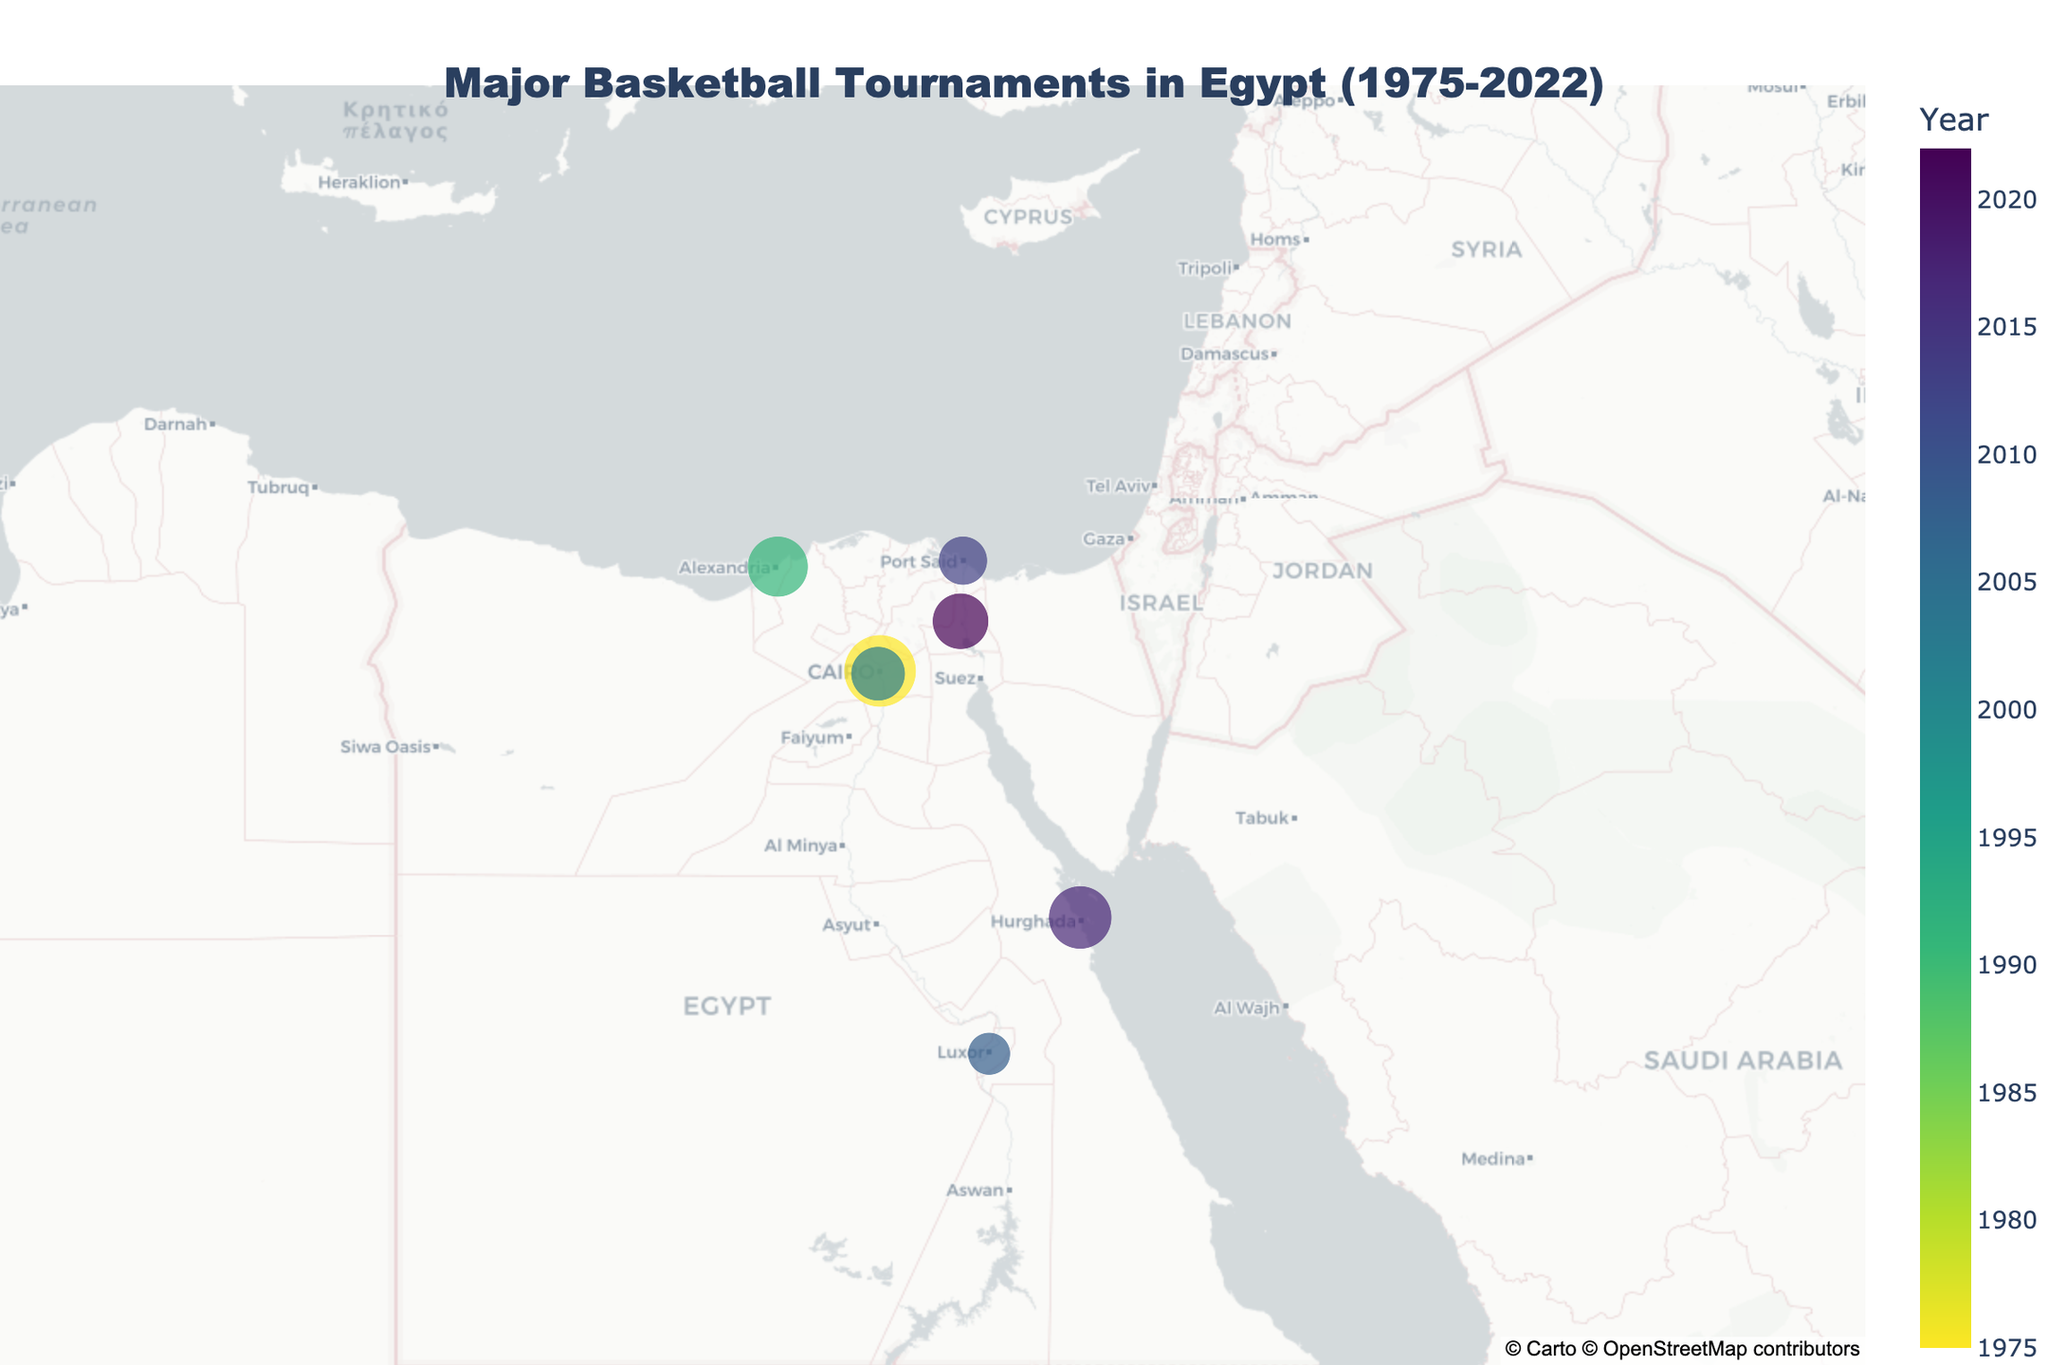What is the title of the figure? The title appears at the top of the figure and is usually larger and centrally positioned. It is often one of the first things to notice when viewing a plot.
Answer: Major Basketball Tournaments in Egypt (1975-2022) Which city hosted the most recent tournament? The figure shows the locations of major basketball tournaments and their respective years. The most recent year listed in the color legend is 2022. Checking visually, the city corresponding to 2022 is Ismailia.
Answer: Ismailia Which tournament had the largest attendance? To find the largest attendance, we look for the biggest circle on the map. The largest circle appears in Cairo, with the hover information confirming that it represents an attendance of 12,000 for the African Basketball Championship in 1975.
Answer: African Basketball Championship How many tournaments were held in Cairo? Each data point represents one tournament. Reviewing the visual data points in Cairo reveals only one circle.
Answer: 1 What is the smallest attendance figure shown in the plot? The smallest circle on the plot reflects the smallest attendance figure. This circle is in Luxor, where the attendance is 4,200 for the FIBA Africa Under-18 Championship in 2008.
Answer: 4200 Which year had the second highest tournament attendance and what was the event? The largest circle indicates the highest attendance, and the second largest circle represents the second highest. The second largest circle, visually identified, corresponds to the year 2017 in Hurghada for the FIBA AfroBasket with an attendance of 9,200.
Answer: 2017, FIBA AfroBasket Compare the tournament attendance in Alexandria (1991) and Hurghada (2017). Which one was higher? Identify the circles representing Alexandria and Hurghada, then check the hover information to compare their attendances. Alexandria's Mediterranean Games in 1991 had 8,500 attendees, while Hurghada's FIBA AfroBasket in 2017 had 9,200 attendees.
Answer: Hurghada What is the average attendance of all listed tournaments? To calculate the average, sum all attendance figures and divide by the number of tournaments: (12000 + 8500 + 6800 + 4200 + 5500 + 9200 + 7300) / 7 = 63,500 / 7 = 9,071.43.
Answer: 9071.43 In which geographical parts of Egypt were most of these tournaments held? By observing the plot, most circles are clustered in the northern part of Egypt (Cairo, Alexandria, Giza, Port Said, Ismailia) compared to southern parts like Luxor and Hurghada. This indicates a higher frequency of tournaments in the northern region.
Answer: Northern Egypt 